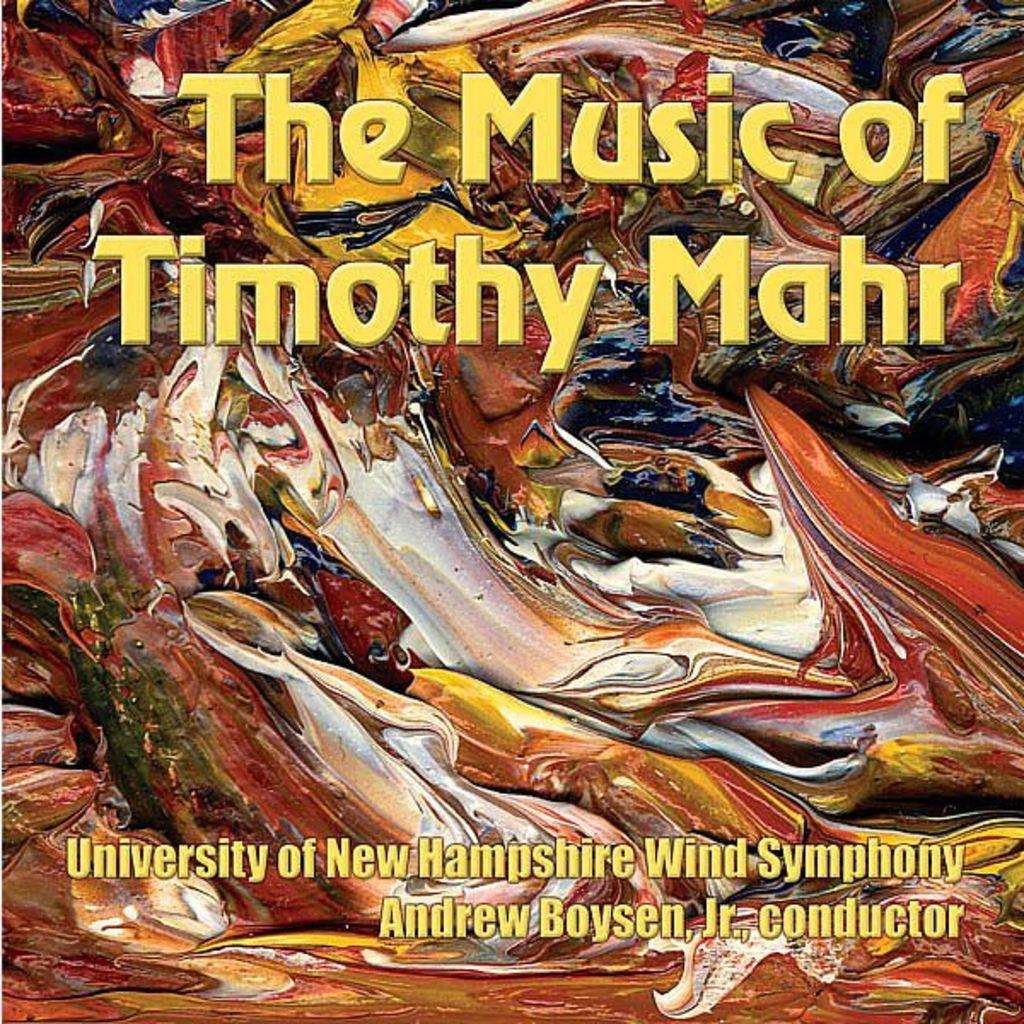<image>
Share a concise interpretation of the image provided. album with abstract painting for the music of timothy mahr 